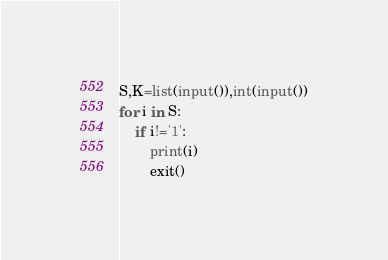Convert code to text. <code><loc_0><loc_0><loc_500><loc_500><_Python_>S,K=list(input()),int(input())
for i in S:
    if i!='1':
        print(i)
        exit()</code> 